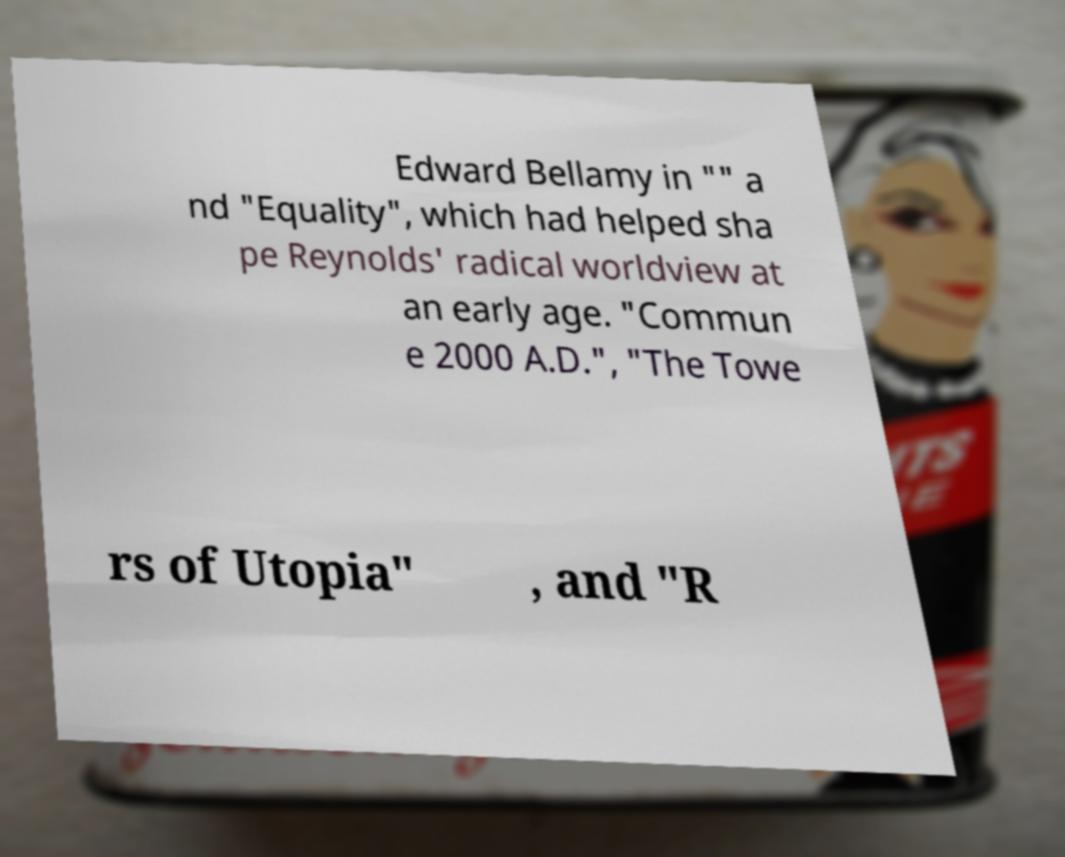Can you read and provide the text displayed in the image?This photo seems to have some interesting text. Can you extract and type it out for me? Edward Bellamy in "" a nd "Equality", which had helped sha pe Reynolds' radical worldview at an early age. "Commun e 2000 A.D.", "The Towe rs of Utopia" , and "R 